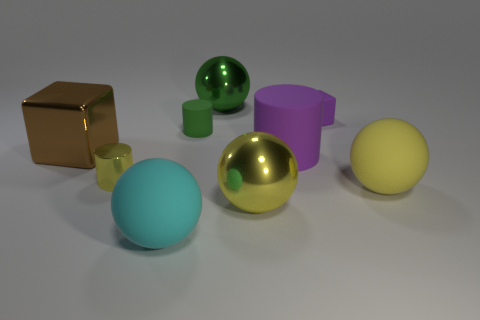Subtract all large rubber cylinders. How many cylinders are left? 2 Add 1 gray cylinders. How many objects exist? 10 Subtract 2 cylinders. How many cylinders are left? 1 Subtract all green spheres. How many spheres are left? 3 Subtract all cubes. How many objects are left? 7 Subtract all purple cylinders. How many yellow spheres are left? 2 Subtract all big brown blocks. Subtract all brown blocks. How many objects are left? 7 Add 3 brown things. How many brown things are left? 4 Add 3 cyan cubes. How many cyan cubes exist? 3 Subtract 0 gray cylinders. How many objects are left? 9 